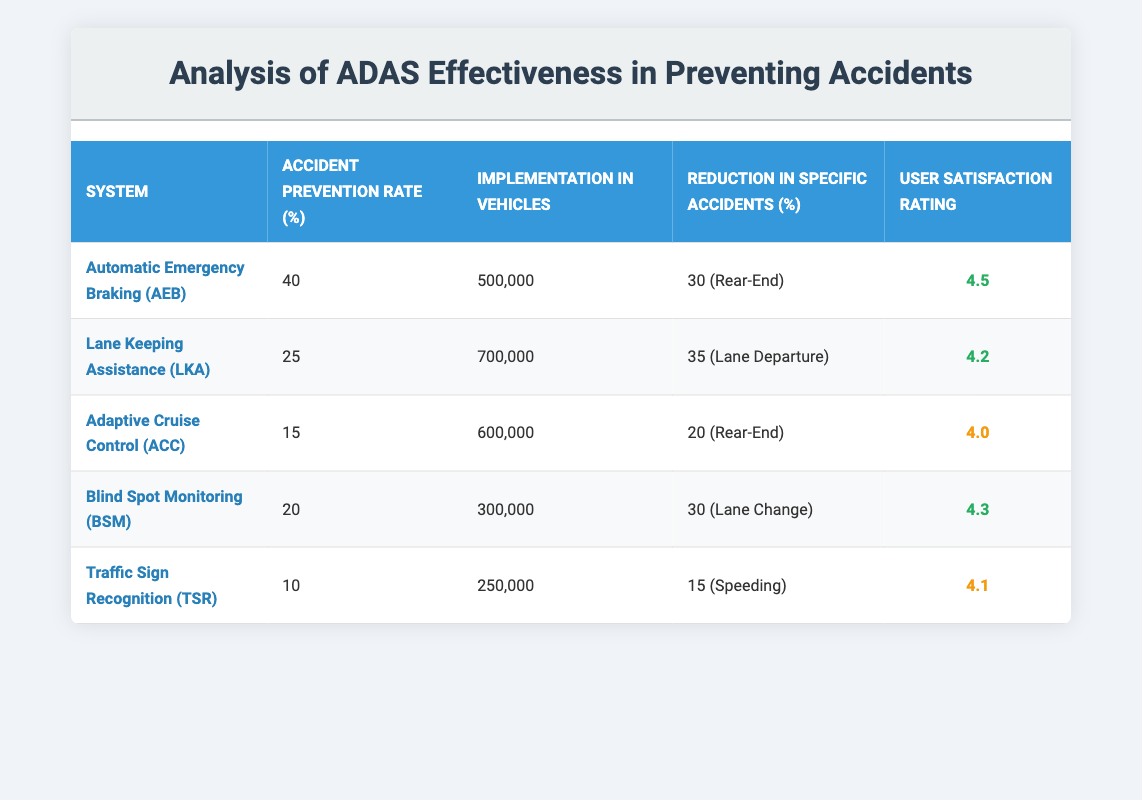What is the accident prevention rate of Automatic Emergency Braking (AEB)? According to the table, the accident prevention rate for Automatic Emergency Braking (AEB) is listed in the respective column. It shows 40%.
Answer: 40% How many vehicles have Lane Keeping Assistance (LKA) implemented? The implementation of Lane Keeping Assistance (LKA) in vehicles can be found in the column that lists the implementation vehicles. It states 700,000 vehicles.
Answer: 700,000 Which ADAS system has the highest user satisfaction rating? By looking at the user satisfaction ratings of each ADAS system in the table, Automatic Emergency Braking (AEB) has the highest rating of 4.5.
Answer: 4.5 What is the reduction in rear-end accidents due to Adaptive Cruise Control (ACC)? The table lists the reduction in rear-end accidents for Adaptive Cruise Control (ACC) in the respective column, showing a reduction of 20%.
Answer: 20% Is the accident prevention rate for Traffic Sign Recognition (TSR) greater than that for Blind Spot Monitoring (BSM)? The accident prevention rate for Traffic Sign Recognition (TSR) is 10%, and for Blind Spot Monitoring (BSM) it is 20%. Since 10% is less than 20%, the statement is false.
Answer: No What is the average user satisfaction rating across all ADAS systems? To calculate the average user satisfaction rating, we add up all the ratings: (4.5 + 4.2 + 4.0 + 4.3 + 4.1) = 21.1. Dividing by the number of systems (5), we get 21.1/5 = 4.22.
Answer: 4.22 How many vehicles implemented systems that have an accident prevention rate of 25% or lower? The systems with an accident prevention rate of 25% or lower are Adaptive Cruise Control (ACC), Blind Spot Monitoring (BSM), and Traffic Sign Recognition (TSR). Their implementation vehicle counts are 600,000, 300,000, and 250,000 respectively. Adding these gives us 600,000 + 300,000 + 250,000 = 1,150,000 vehicles.
Answer: 1,150,000 Which ADAS has the least amount of implementation vehicles and what is its accident prevention rate? Reviewing the implementation numbers, Traffic Sign Recognition (TSR) has the least with 250,000 vehicles. Its accident prevention rate is 10%.
Answer: 10% (250,000 vehicles) Do any of the systems have a user satisfaction rating below 4.0? From the user satisfaction ratings listed, Adaptive Cruise Control (ACC) has a rating of 4.0, which is not below, while Traffic Sign Recognition (TSR) has a rating of 4.1, thus no system has a rating below 4.0.
Answer: No 